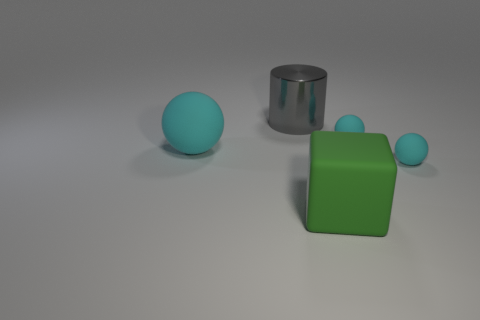Are there any other things that have the same material as the gray thing?
Provide a short and direct response. No. Is the number of big green cubes less than the number of big yellow rubber objects?
Make the answer very short. No. Is the color of the big object right of the large metallic cylinder the same as the big rubber sphere?
Keep it short and to the point. No. How many purple spheres have the same size as the block?
Keep it short and to the point. 0. Is there a metallic object of the same color as the cylinder?
Offer a very short reply. No. Are the large cylinder and the green object made of the same material?
Your answer should be very brief. No. What number of other objects have the same shape as the big cyan thing?
Make the answer very short. 2. The big thing that is made of the same material as the big block is what shape?
Offer a terse response. Sphere. The large object on the left side of the big metallic cylinder that is behind the large ball is what color?
Offer a terse response. Cyan. Do the large shiny cylinder and the big matte sphere have the same color?
Make the answer very short. No. 